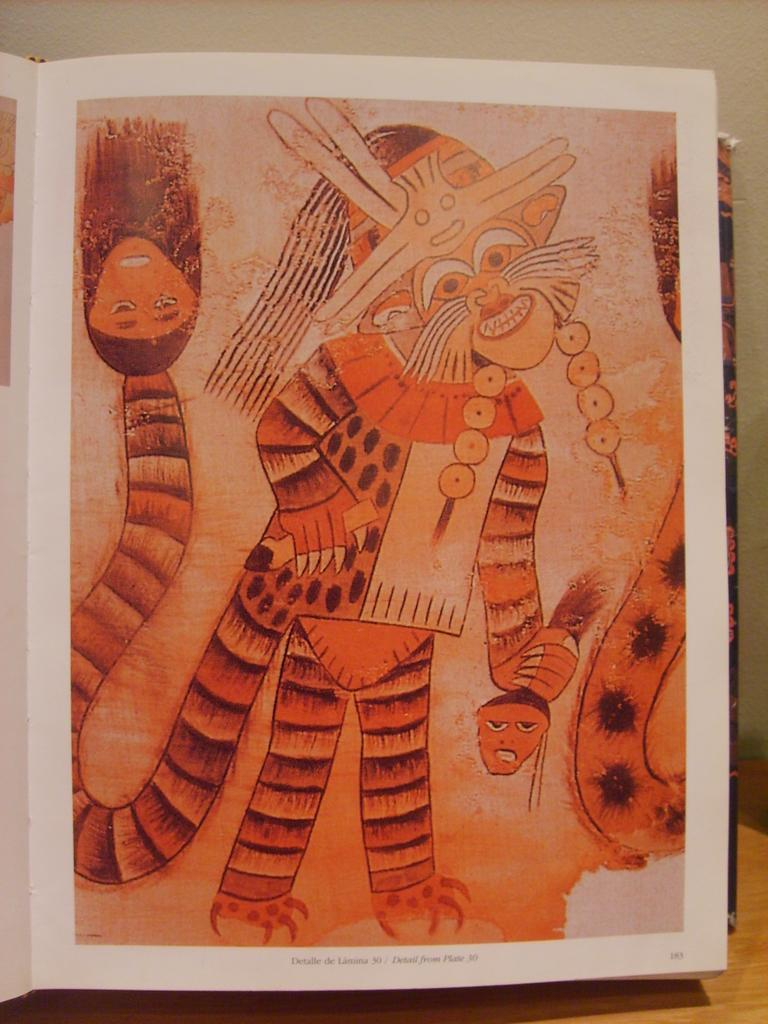What is contained within the book in the image? There are paintings in a book in the image. What can be seen behind the book in the image? There is a wall in the image. Can you describe the setting of the image? The image is likely taken in a room, as there is a wall visible. What type of juice is being squeezed from the bat in the image? There is no bat or juice present in the image; it only features a book with paintings and a wall. 